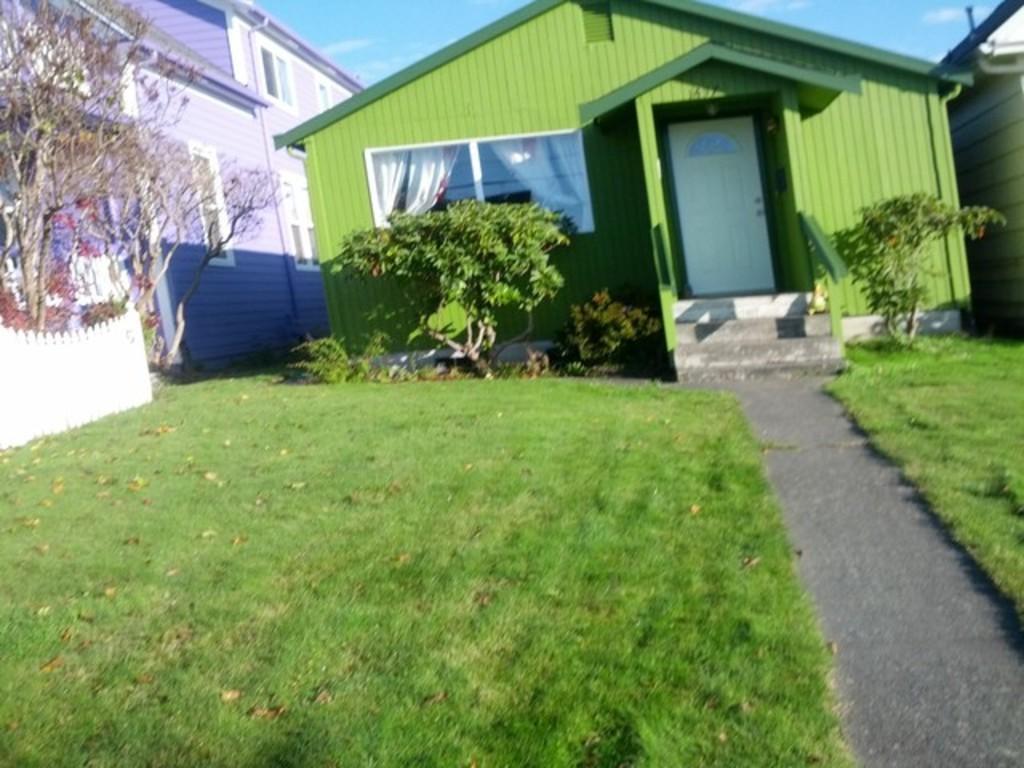How would you summarize this image in a sentence or two? In this picture we can see some houses, around we can see some grass and trees. 